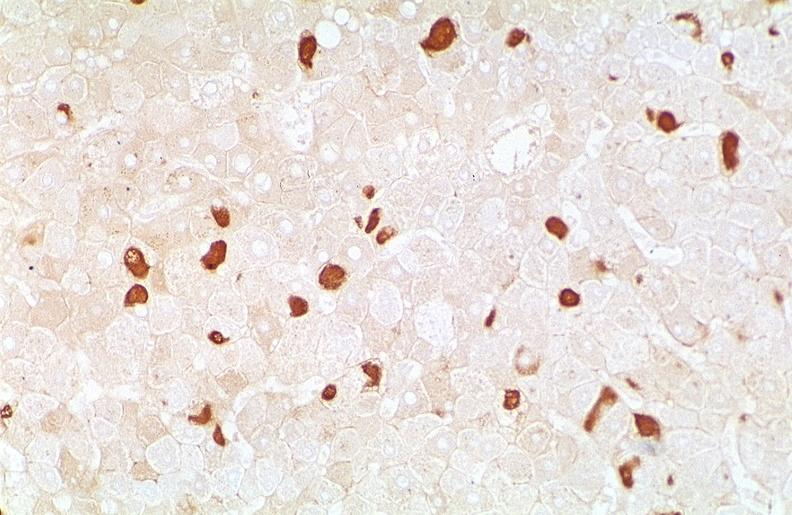what does this image show?
Answer the question using a single word or phrase. Hepatitis b virus 